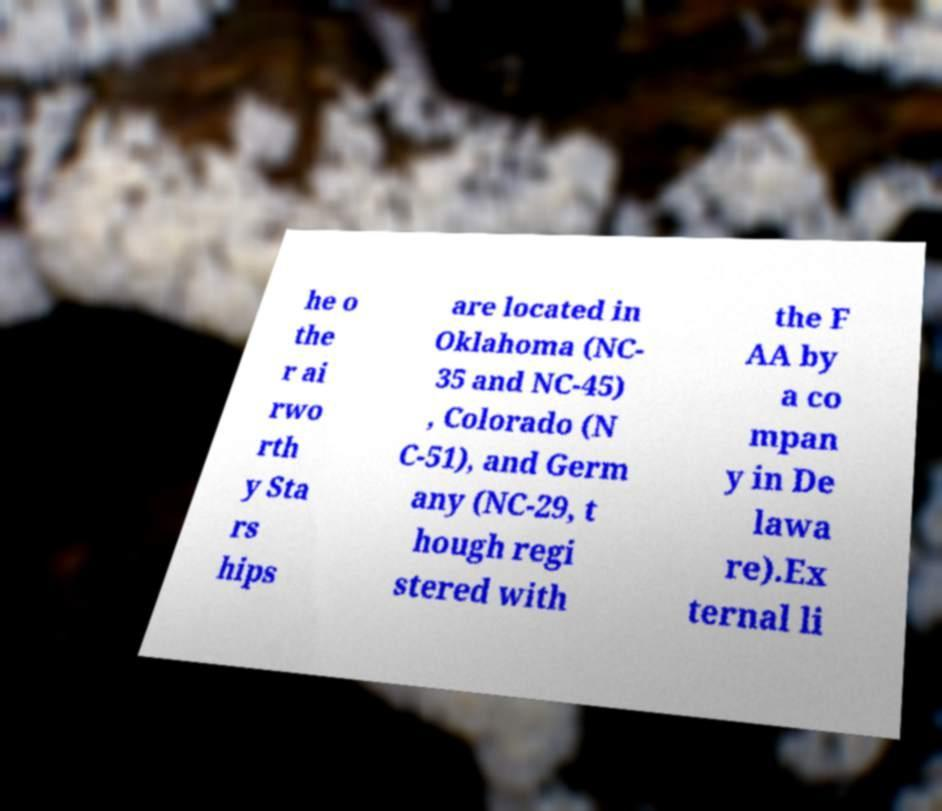What messages or text are displayed in this image? I need them in a readable, typed format. he o the r ai rwo rth y Sta rs hips are located in Oklahoma (NC- 35 and NC-45) , Colorado (N C-51), and Germ any (NC-29, t hough regi stered with the F AA by a co mpan y in De lawa re).Ex ternal li 